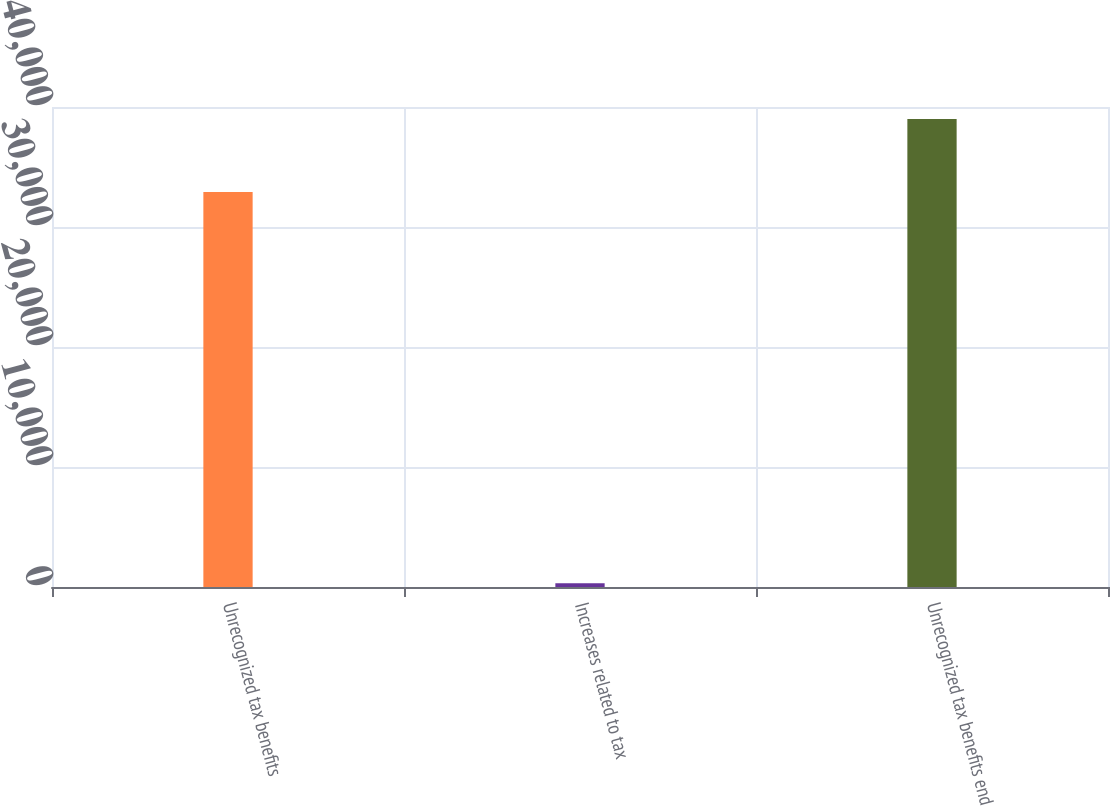Convert chart to OTSL. <chart><loc_0><loc_0><loc_500><loc_500><bar_chart><fcel>Unrecognized tax benefits<fcel>Increases related to tax<fcel>Unrecognized tax benefits end<nl><fcel>32911<fcel>318<fcel>38992<nl></chart> 